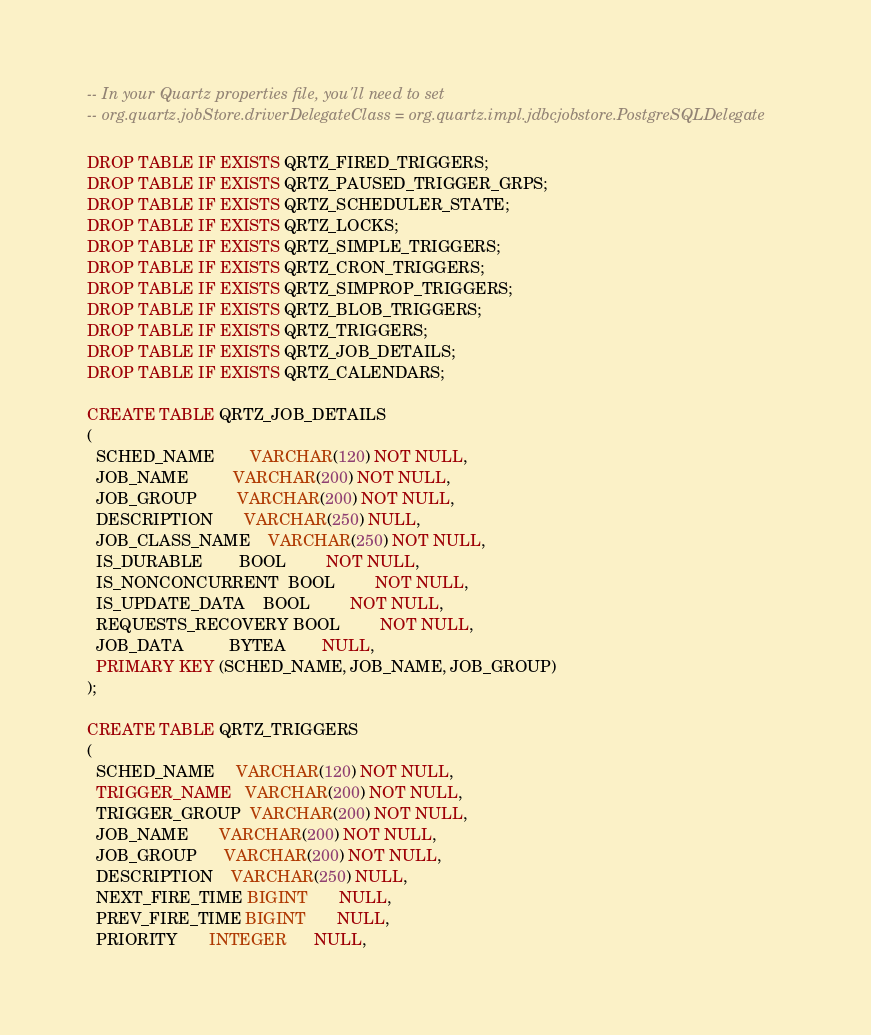Convert code to text. <code><loc_0><loc_0><loc_500><loc_500><_SQL_>-- In your Quartz properties file, you'll need to set 
-- org.quartz.jobStore.driverDelegateClass = org.quartz.impl.jdbcjobstore.PostgreSQLDelegate

DROP TABLE IF EXISTS QRTZ_FIRED_TRIGGERS;
DROP TABLE IF EXISTS QRTZ_PAUSED_TRIGGER_GRPS;
DROP TABLE IF EXISTS QRTZ_SCHEDULER_STATE;
DROP TABLE IF EXISTS QRTZ_LOCKS;
DROP TABLE IF EXISTS QRTZ_SIMPLE_TRIGGERS;
DROP TABLE IF EXISTS QRTZ_CRON_TRIGGERS;
DROP TABLE IF EXISTS QRTZ_SIMPROP_TRIGGERS;
DROP TABLE IF EXISTS QRTZ_BLOB_TRIGGERS;
DROP TABLE IF EXISTS QRTZ_TRIGGERS;
DROP TABLE IF EXISTS QRTZ_JOB_DETAILS;
DROP TABLE IF EXISTS QRTZ_CALENDARS;

CREATE TABLE QRTZ_JOB_DETAILS
(
  SCHED_NAME        VARCHAR(120) NOT NULL,
  JOB_NAME          VARCHAR(200) NOT NULL,
  JOB_GROUP         VARCHAR(200) NOT NULL,
  DESCRIPTION       VARCHAR(250) NULL,
  JOB_CLASS_NAME    VARCHAR(250) NOT NULL,
  IS_DURABLE        BOOL         NOT NULL,
  IS_NONCONCURRENT  BOOL         NOT NULL,
  IS_UPDATE_DATA    BOOL         NOT NULL,
  REQUESTS_RECOVERY BOOL         NOT NULL,
  JOB_DATA          BYTEA        NULL,
  PRIMARY KEY (SCHED_NAME, JOB_NAME, JOB_GROUP)
);

CREATE TABLE QRTZ_TRIGGERS
(
  SCHED_NAME     VARCHAR(120) NOT NULL,
  TRIGGER_NAME   VARCHAR(200) NOT NULL,
  TRIGGER_GROUP  VARCHAR(200) NOT NULL,
  JOB_NAME       VARCHAR(200) NOT NULL,
  JOB_GROUP      VARCHAR(200) NOT NULL,
  DESCRIPTION    VARCHAR(250) NULL,
  NEXT_FIRE_TIME BIGINT       NULL,
  PREV_FIRE_TIME BIGINT       NULL,
  PRIORITY       INTEGER      NULL,</code> 